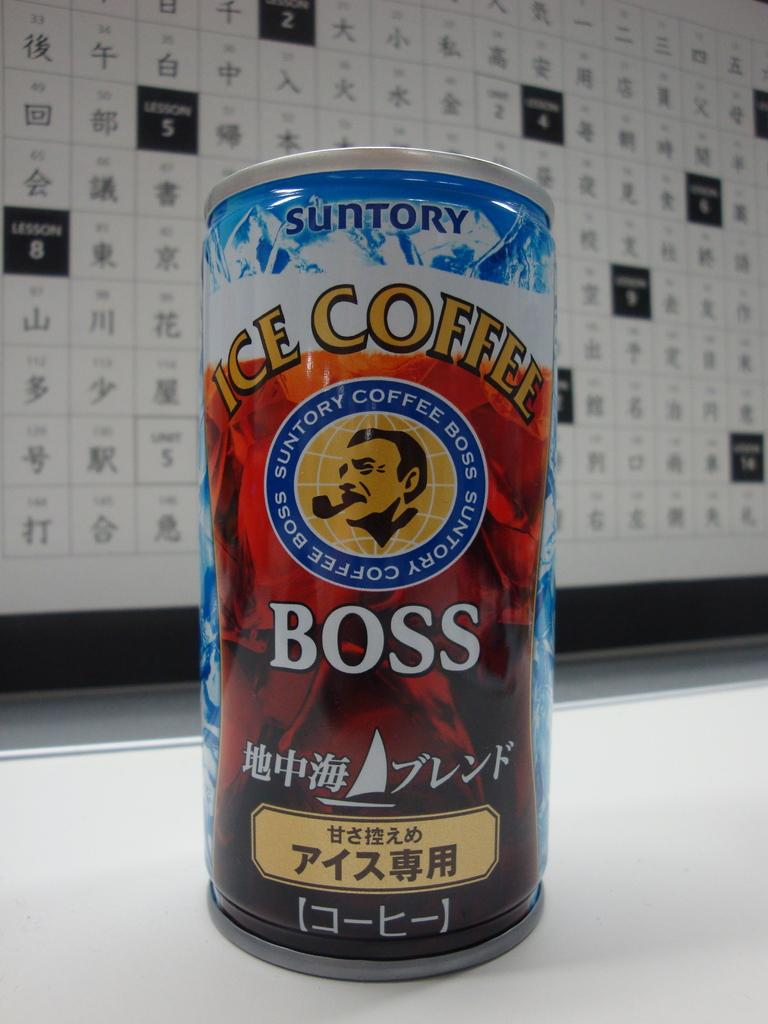<image>
Relay a brief, clear account of the picture shown. A can of Suntory Ice coffee infront of a calendar 